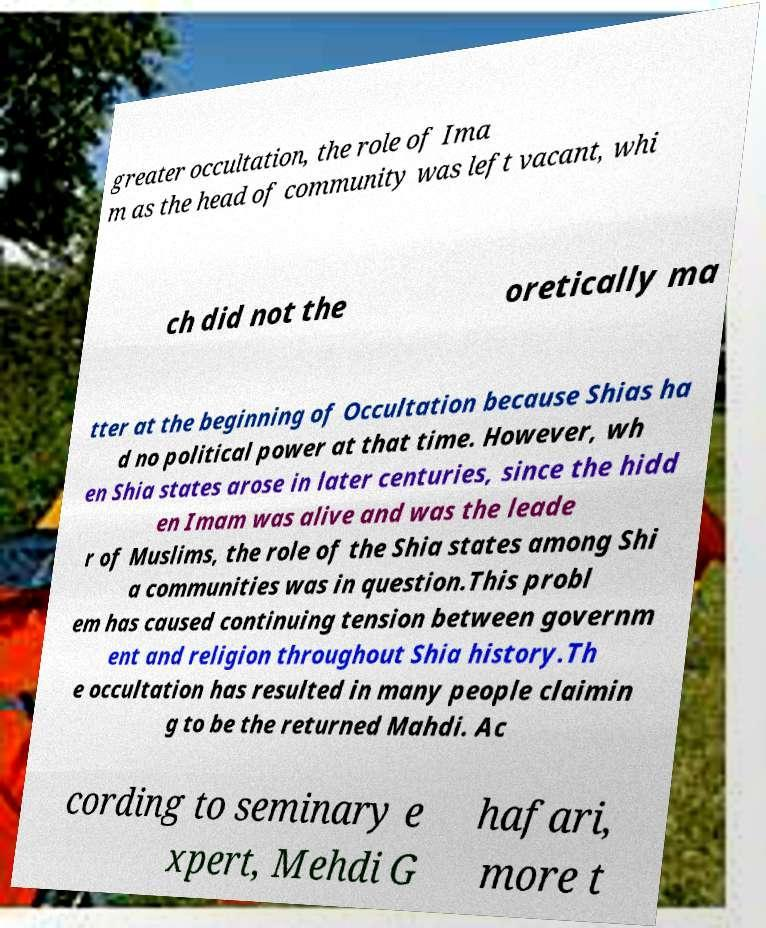What messages or text are displayed in this image? I need them in a readable, typed format. greater occultation, the role of Ima m as the head of community was left vacant, whi ch did not the oretically ma tter at the beginning of Occultation because Shias ha d no political power at that time. However, wh en Shia states arose in later centuries, since the hidd en Imam was alive and was the leade r of Muslims, the role of the Shia states among Shi a communities was in question.This probl em has caused continuing tension between governm ent and religion throughout Shia history.Th e occultation has resulted in many people claimin g to be the returned Mahdi. Ac cording to seminary e xpert, Mehdi G hafari, more t 